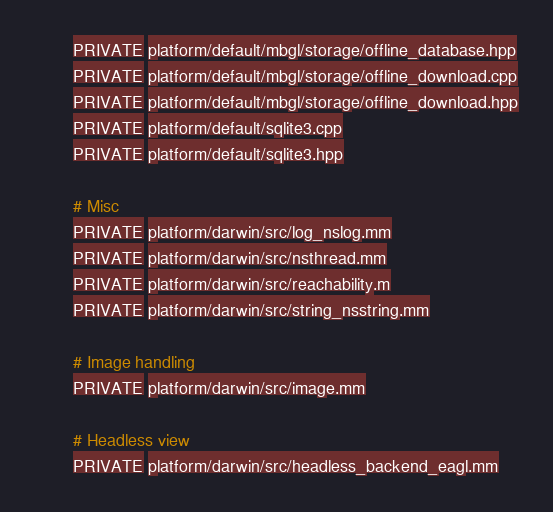<code> <loc_0><loc_0><loc_500><loc_500><_CMake_>        PRIVATE platform/default/mbgl/storage/offline_database.hpp
        PRIVATE platform/default/mbgl/storage/offline_download.cpp
        PRIVATE platform/default/mbgl/storage/offline_download.hpp
        PRIVATE platform/default/sqlite3.cpp
        PRIVATE platform/default/sqlite3.hpp

        # Misc
        PRIVATE platform/darwin/src/log_nslog.mm
        PRIVATE platform/darwin/src/nsthread.mm
        PRIVATE platform/darwin/src/reachability.m
        PRIVATE platform/darwin/src/string_nsstring.mm

        # Image handling
        PRIVATE platform/darwin/src/image.mm

        # Headless view
        PRIVATE platform/darwin/src/headless_backend_eagl.mm</code> 